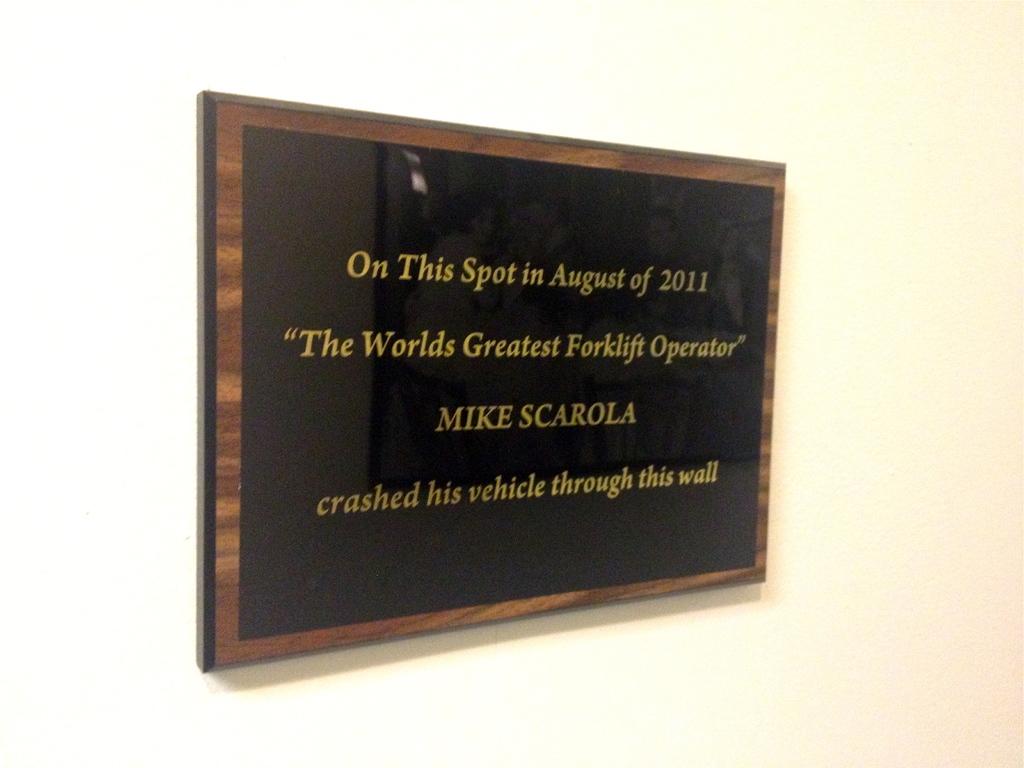Who is the world's greatest forklift operator?
Give a very brief answer. Mike scarola. Is this a plaque making fun of someone named mike scarola?
Give a very brief answer. Yes. 